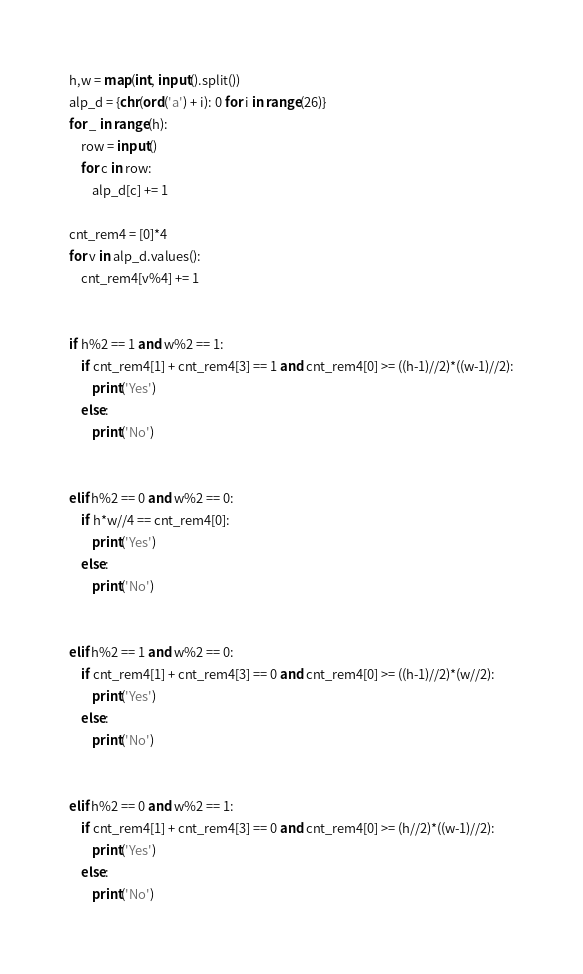Convert code to text. <code><loc_0><loc_0><loc_500><loc_500><_Python_>h,w = map(int, input().split())
alp_d = {chr(ord('a') + i): 0 for i in range(26)}
for _ in range(h):
    row = input()
    for c in row:
        alp_d[c] += 1

cnt_rem4 = [0]*4
for v in alp_d.values():
    cnt_rem4[v%4] += 1


if h%2 == 1 and w%2 == 1:
    if cnt_rem4[1] + cnt_rem4[3] == 1 and cnt_rem4[0] >= ((h-1)//2)*((w-1)//2):
        print('Yes')
    else:
        print('No')


elif h%2 == 0 and w%2 == 0:
    if h*w//4 == cnt_rem4[0]:
        print('Yes')
    else:
        print('No')


elif h%2 == 1 and w%2 == 0:
    if cnt_rem4[1] + cnt_rem4[3] == 0 and cnt_rem4[0] >= ((h-1)//2)*(w//2):
        print('Yes')
    else:
        print('No')


elif h%2 == 0 and w%2 == 1:
    if cnt_rem4[1] + cnt_rem4[3] == 0 and cnt_rem4[0] >= (h//2)*((w-1)//2):
        print('Yes')
    else:
        print('No')</code> 